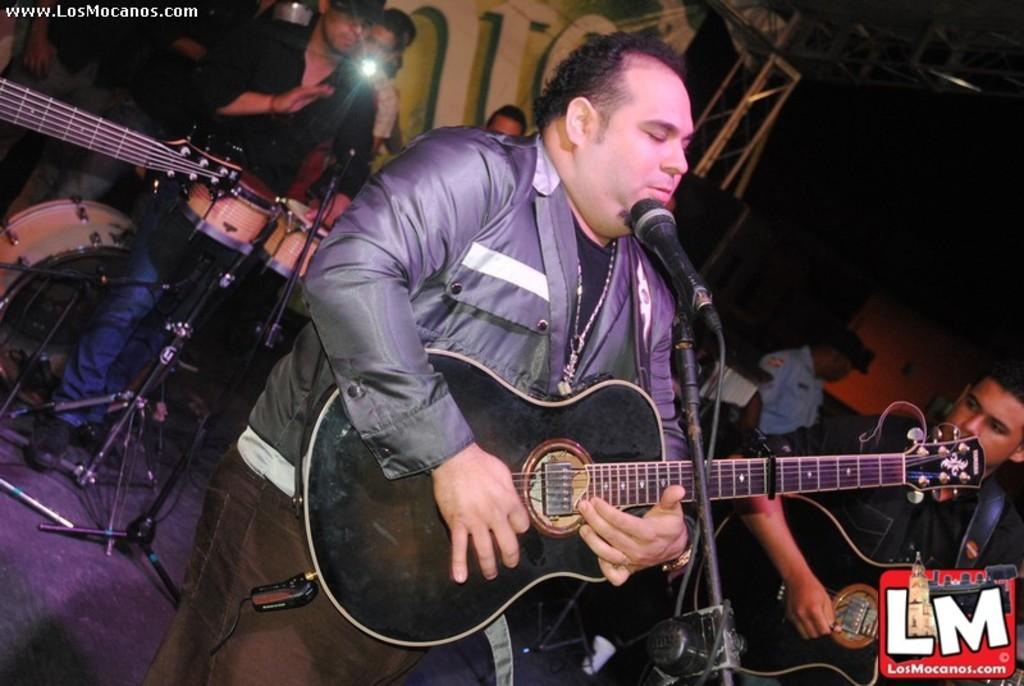What is the man in the image doing? The man is playing a guitar in the image. What is in front of the man? There is a microphone in front of the man. What are the other persons in the image doing? The other persons in the image are playing musical instruments in the background. What can be seen in the background of the image? There is a banner visible in the background. What type of business is being conducted in the image? There is no indication of a business being conducted in the image; it features a man playing a guitar and other musicians. Can you see a cat in the image? There is no cat present in the image. 